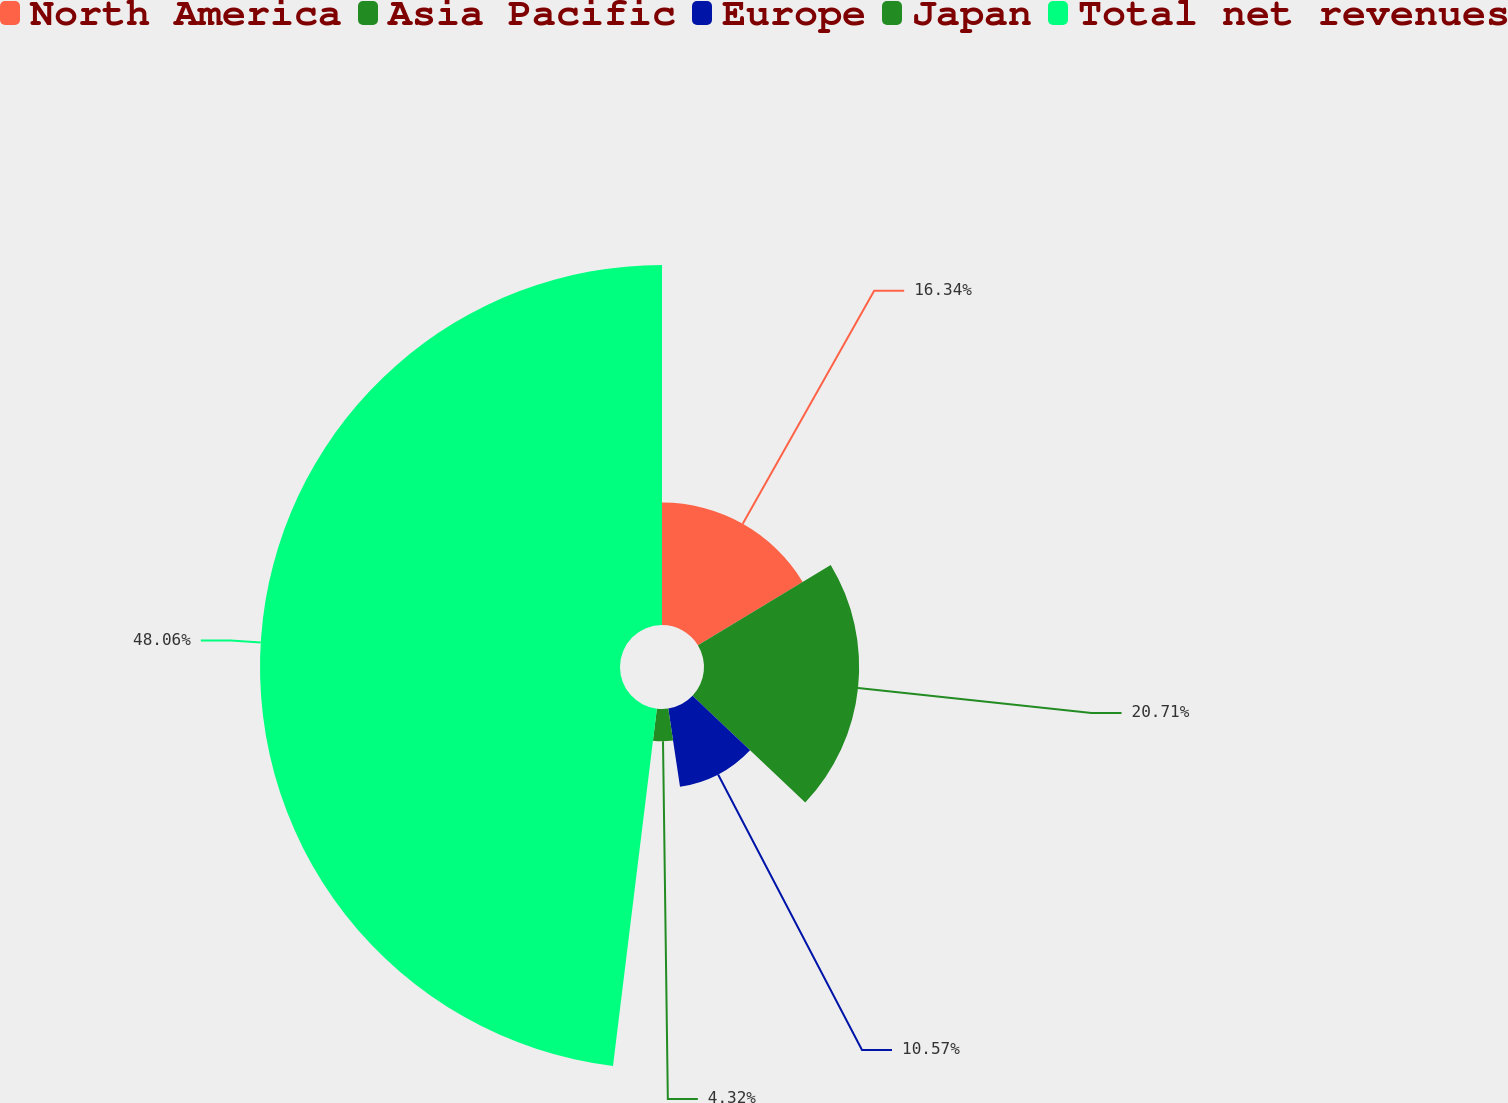Convert chart to OTSL. <chart><loc_0><loc_0><loc_500><loc_500><pie_chart><fcel>North America<fcel>Asia Pacific<fcel>Europe<fcel>Japan<fcel>Total net revenues<nl><fcel>16.34%<fcel>20.71%<fcel>10.57%<fcel>4.32%<fcel>48.05%<nl></chart> 